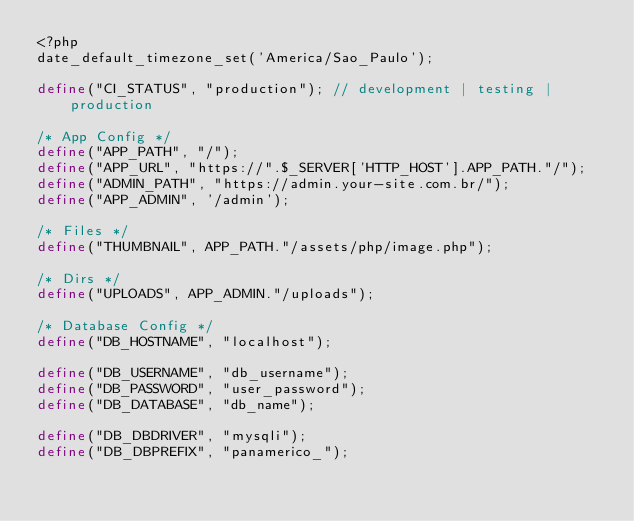Convert code to text. <code><loc_0><loc_0><loc_500><loc_500><_PHP_><?php
date_default_timezone_set('America/Sao_Paulo');

define("CI_STATUS", "production"); // development | testing | production

/* App Config */
define("APP_PATH", "/");
define("APP_URL", "https://".$_SERVER['HTTP_HOST'].APP_PATH."/");
define("ADMIN_PATH", "https://admin.your-site.com.br/");
define("APP_ADMIN", '/admin');

/* Files */
define("THUMBNAIL", APP_PATH."/assets/php/image.php");

/* Dirs */
define("UPLOADS", APP_ADMIN."/uploads");

/* Database Config */
define("DB_HOSTNAME", "localhost");

define("DB_USERNAME", "db_username");
define("DB_PASSWORD", "user_password");
define("DB_DATABASE", "db_name");

define("DB_DBDRIVER", "mysqli");
define("DB_DBPREFIX", "panamerico_");

</code> 